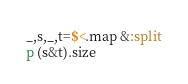Convert code to text. <code><loc_0><loc_0><loc_500><loc_500><_Ruby_>_,s,_,t=$<.map &:split
p (s&t).size
</code> 